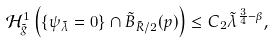<formula> <loc_0><loc_0><loc_500><loc_500>\mathcal { H } _ { \tilde { g } } ^ { 1 } \left ( \{ \psi _ { \tilde { \lambda } } = 0 \} \cap \tilde { B } _ { \tilde { R } / 2 } ( p ) \right ) \leq C _ { 2 } { \tilde { \lambda } } ^ { \frac { 3 } { 4 } - \beta } ,</formula> 